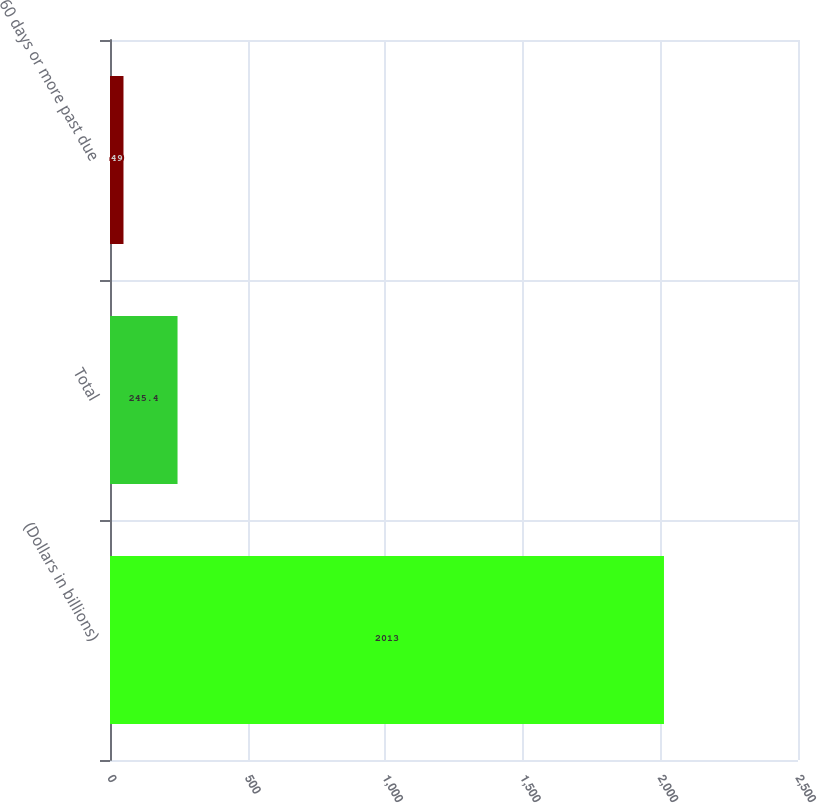Convert chart. <chart><loc_0><loc_0><loc_500><loc_500><bar_chart><fcel>(Dollars in billions)<fcel>Total<fcel>60 days or more past due<nl><fcel>2013<fcel>245.4<fcel>49<nl></chart> 